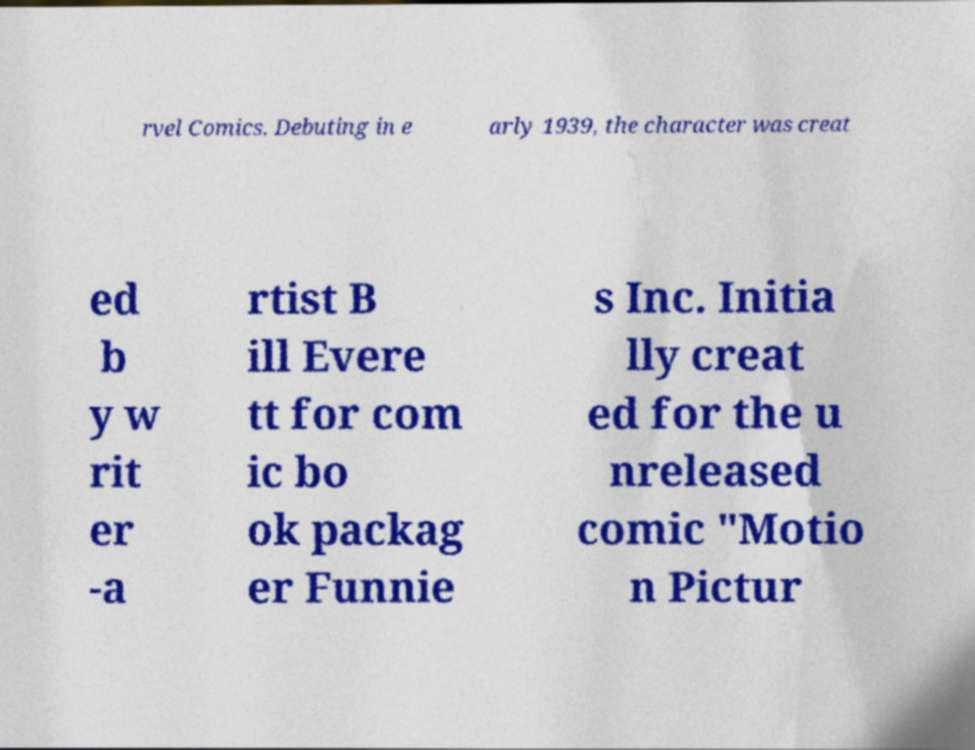I need the written content from this picture converted into text. Can you do that? rvel Comics. Debuting in e arly 1939, the character was creat ed b y w rit er -a rtist B ill Evere tt for com ic bo ok packag er Funnie s Inc. Initia lly creat ed for the u nreleased comic "Motio n Pictur 